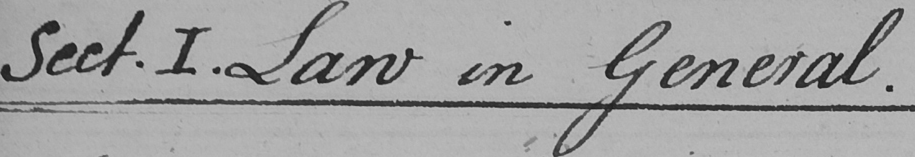Can you tell me what this handwritten text says? Sect . I . Law in General . 